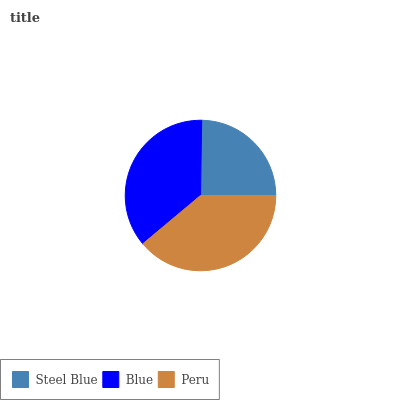Is Steel Blue the minimum?
Answer yes or no. Yes. Is Peru the maximum?
Answer yes or no. Yes. Is Blue the minimum?
Answer yes or no. No. Is Blue the maximum?
Answer yes or no. No. Is Blue greater than Steel Blue?
Answer yes or no. Yes. Is Steel Blue less than Blue?
Answer yes or no. Yes. Is Steel Blue greater than Blue?
Answer yes or no. No. Is Blue less than Steel Blue?
Answer yes or no. No. Is Blue the high median?
Answer yes or no. Yes. Is Blue the low median?
Answer yes or no. Yes. Is Steel Blue the high median?
Answer yes or no. No. Is Steel Blue the low median?
Answer yes or no. No. 